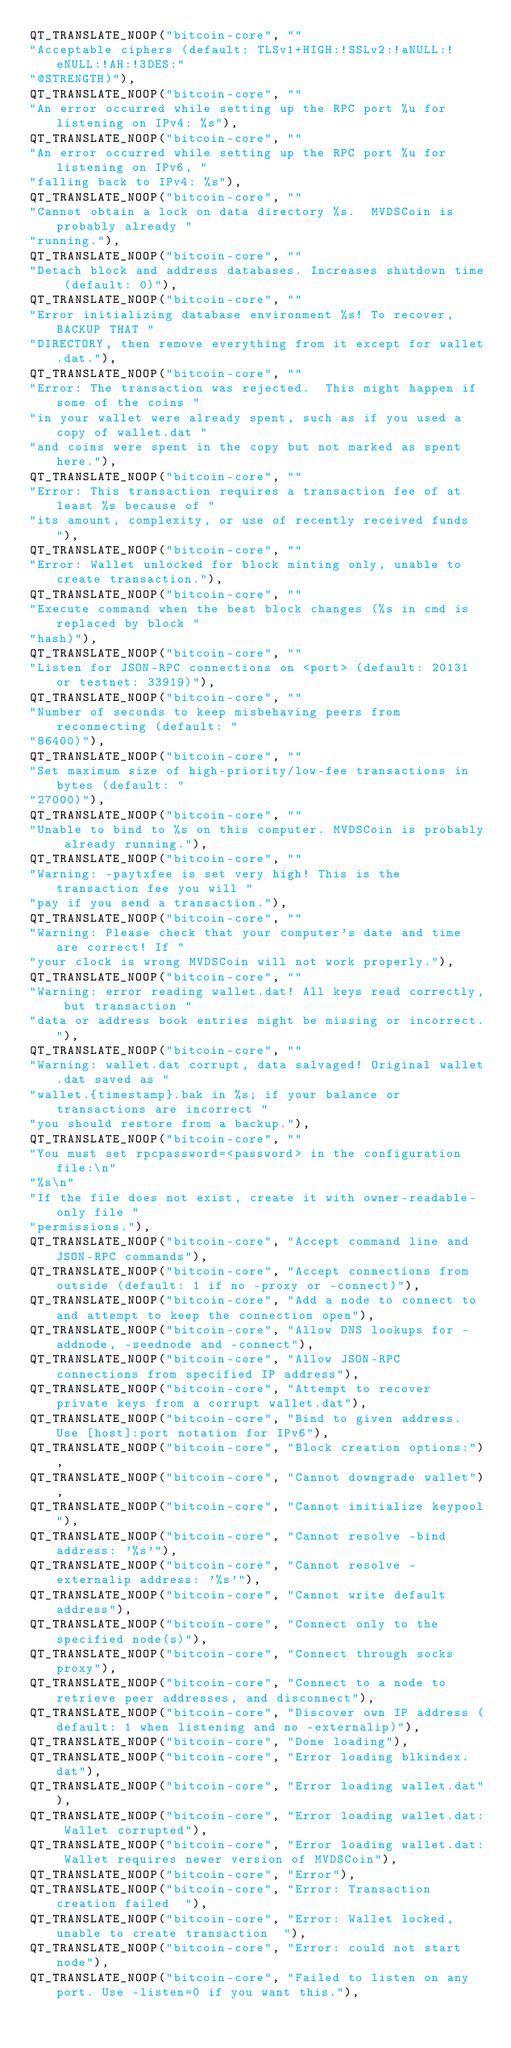Convert code to text. <code><loc_0><loc_0><loc_500><loc_500><_C++_>QT_TRANSLATE_NOOP("bitcoin-core", ""
"Acceptable ciphers (default: TLSv1+HIGH:!SSLv2:!aNULL:!eNULL:!AH:!3DES:"
"@STRENGTH)"),
QT_TRANSLATE_NOOP("bitcoin-core", ""
"An error occurred while setting up the RPC port %u for listening on IPv4: %s"),
QT_TRANSLATE_NOOP("bitcoin-core", ""
"An error occurred while setting up the RPC port %u for listening on IPv6, "
"falling back to IPv4: %s"),
QT_TRANSLATE_NOOP("bitcoin-core", ""
"Cannot obtain a lock on data directory %s.  MVDSCoin is probably already "
"running."),
QT_TRANSLATE_NOOP("bitcoin-core", ""
"Detach block and address databases. Increases shutdown time (default: 0)"),
QT_TRANSLATE_NOOP("bitcoin-core", ""
"Error initializing database environment %s! To recover, BACKUP THAT "
"DIRECTORY, then remove everything from it except for wallet.dat."),
QT_TRANSLATE_NOOP("bitcoin-core", ""
"Error: The transaction was rejected.  This might happen if some of the coins "
"in your wallet were already spent, such as if you used a copy of wallet.dat "
"and coins were spent in the copy but not marked as spent here."),
QT_TRANSLATE_NOOP("bitcoin-core", ""
"Error: This transaction requires a transaction fee of at least %s because of "
"its amount, complexity, or use of recently received funds  "),
QT_TRANSLATE_NOOP("bitcoin-core", ""
"Error: Wallet unlocked for block minting only, unable to create transaction."),
QT_TRANSLATE_NOOP("bitcoin-core", ""
"Execute command when the best block changes (%s in cmd is replaced by block "
"hash)"),
QT_TRANSLATE_NOOP("bitcoin-core", ""
"Listen for JSON-RPC connections on <port> (default: 20131 or testnet: 33919)"),
QT_TRANSLATE_NOOP("bitcoin-core", ""
"Number of seconds to keep misbehaving peers from reconnecting (default: "
"86400)"),
QT_TRANSLATE_NOOP("bitcoin-core", ""
"Set maximum size of high-priority/low-fee transactions in bytes (default: "
"27000)"),
QT_TRANSLATE_NOOP("bitcoin-core", ""
"Unable to bind to %s on this computer. MVDSCoin is probably already running."),
QT_TRANSLATE_NOOP("bitcoin-core", ""
"Warning: -paytxfee is set very high! This is the transaction fee you will "
"pay if you send a transaction."),
QT_TRANSLATE_NOOP("bitcoin-core", ""
"Warning: Please check that your computer's date and time are correct! If "
"your clock is wrong MVDSCoin will not work properly."),
QT_TRANSLATE_NOOP("bitcoin-core", ""
"Warning: error reading wallet.dat! All keys read correctly, but transaction "
"data or address book entries might be missing or incorrect."),
QT_TRANSLATE_NOOP("bitcoin-core", ""
"Warning: wallet.dat corrupt, data salvaged! Original wallet.dat saved as "
"wallet.{timestamp}.bak in %s; if your balance or transactions are incorrect "
"you should restore from a backup."),
QT_TRANSLATE_NOOP("bitcoin-core", ""
"You must set rpcpassword=<password> in the configuration file:\n"
"%s\n"
"If the file does not exist, create it with owner-readable-only file "
"permissions."),
QT_TRANSLATE_NOOP("bitcoin-core", "Accept command line and JSON-RPC commands"),
QT_TRANSLATE_NOOP("bitcoin-core", "Accept connections from outside (default: 1 if no -proxy or -connect)"),
QT_TRANSLATE_NOOP("bitcoin-core", "Add a node to connect to and attempt to keep the connection open"),
QT_TRANSLATE_NOOP("bitcoin-core", "Allow DNS lookups for -addnode, -seednode and -connect"),
QT_TRANSLATE_NOOP("bitcoin-core", "Allow JSON-RPC connections from specified IP address"),
QT_TRANSLATE_NOOP("bitcoin-core", "Attempt to recover private keys from a corrupt wallet.dat"),
QT_TRANSLATE_NOOP("bitcoin-core", "Bind to given address. Use [host]:port notation for IPv6"),
QT_TRANSLATE_NOOP("bitcoin-core", "Block creation options:"),
QT_TRANSLATE_NOOP("bitcoin-core", "Cannot downgrade wallet"),
QT_TRANSLATE_NOOP("bitcoin-core", "Cannot initialize keypool"),
QT_TRANSLATE_NOOP("bitcoin-core", "Cannot resolve -bind address: '%s'"),
QT_TRANSLATE_NOOP("bitcoin-core", "Cannot resolve -externalip address: '%s'"),
QT_TRANSLATE_NOOP("bitcoin-core", "Cannot write default address"),
QT_TRANSLATE_NOOP("bitcoin-core", "Connect only to the specified node(s)"),
QT_TRANSLATE_NOOP("bitcoin-core", "Connect through socks proxy"),
QT_TRANSLATE_NOOP("bitcoin-core", "Connect to a node to retrieve peer addresses, and disconnect"),
QT_TRANSLATE_NOOP("bitcoin-core", "Discover own IP address (default: 1 when listening and no -externalip)"),
QT_TRANSLATE_NOOP("bitcoin-core", "Done loading"),
QT_TRANSLATE_NOOP("bitcoin-core", "Error loading blkindex.dat"),
QT_TRANSLATE_NOOP("bitcoin-core", "Error loading wallet.dat"),
QT_TRANSLATE_NOOP("bitcoin-core", "Error loading wallet.dat: Wallet corrupted"),
QT_TRANSLATE_NOOP("bitcoin-core", "Error loading wallet.dat: Wallet requires newer version of MVDSCoin"),
QT_TRANSLATE_NOOP("bitcoin-core", "Error"),
QT_TRANSLATE_NOOP("bitcoin-core", "Error: Transaction creation failed  "),
QT_TRANSLATE_NOOP("bitcoin-core", "Error: Wallet locked, unable to create transaction  "),
QT_TRANSLATE_NOOP("bitcoin-core", "Error: could not start node"),
QT_TRANSLATE_NOOP("bitcoin-core", "Failed to listen on any port. Use -listen=0 if you want this."),</code> 